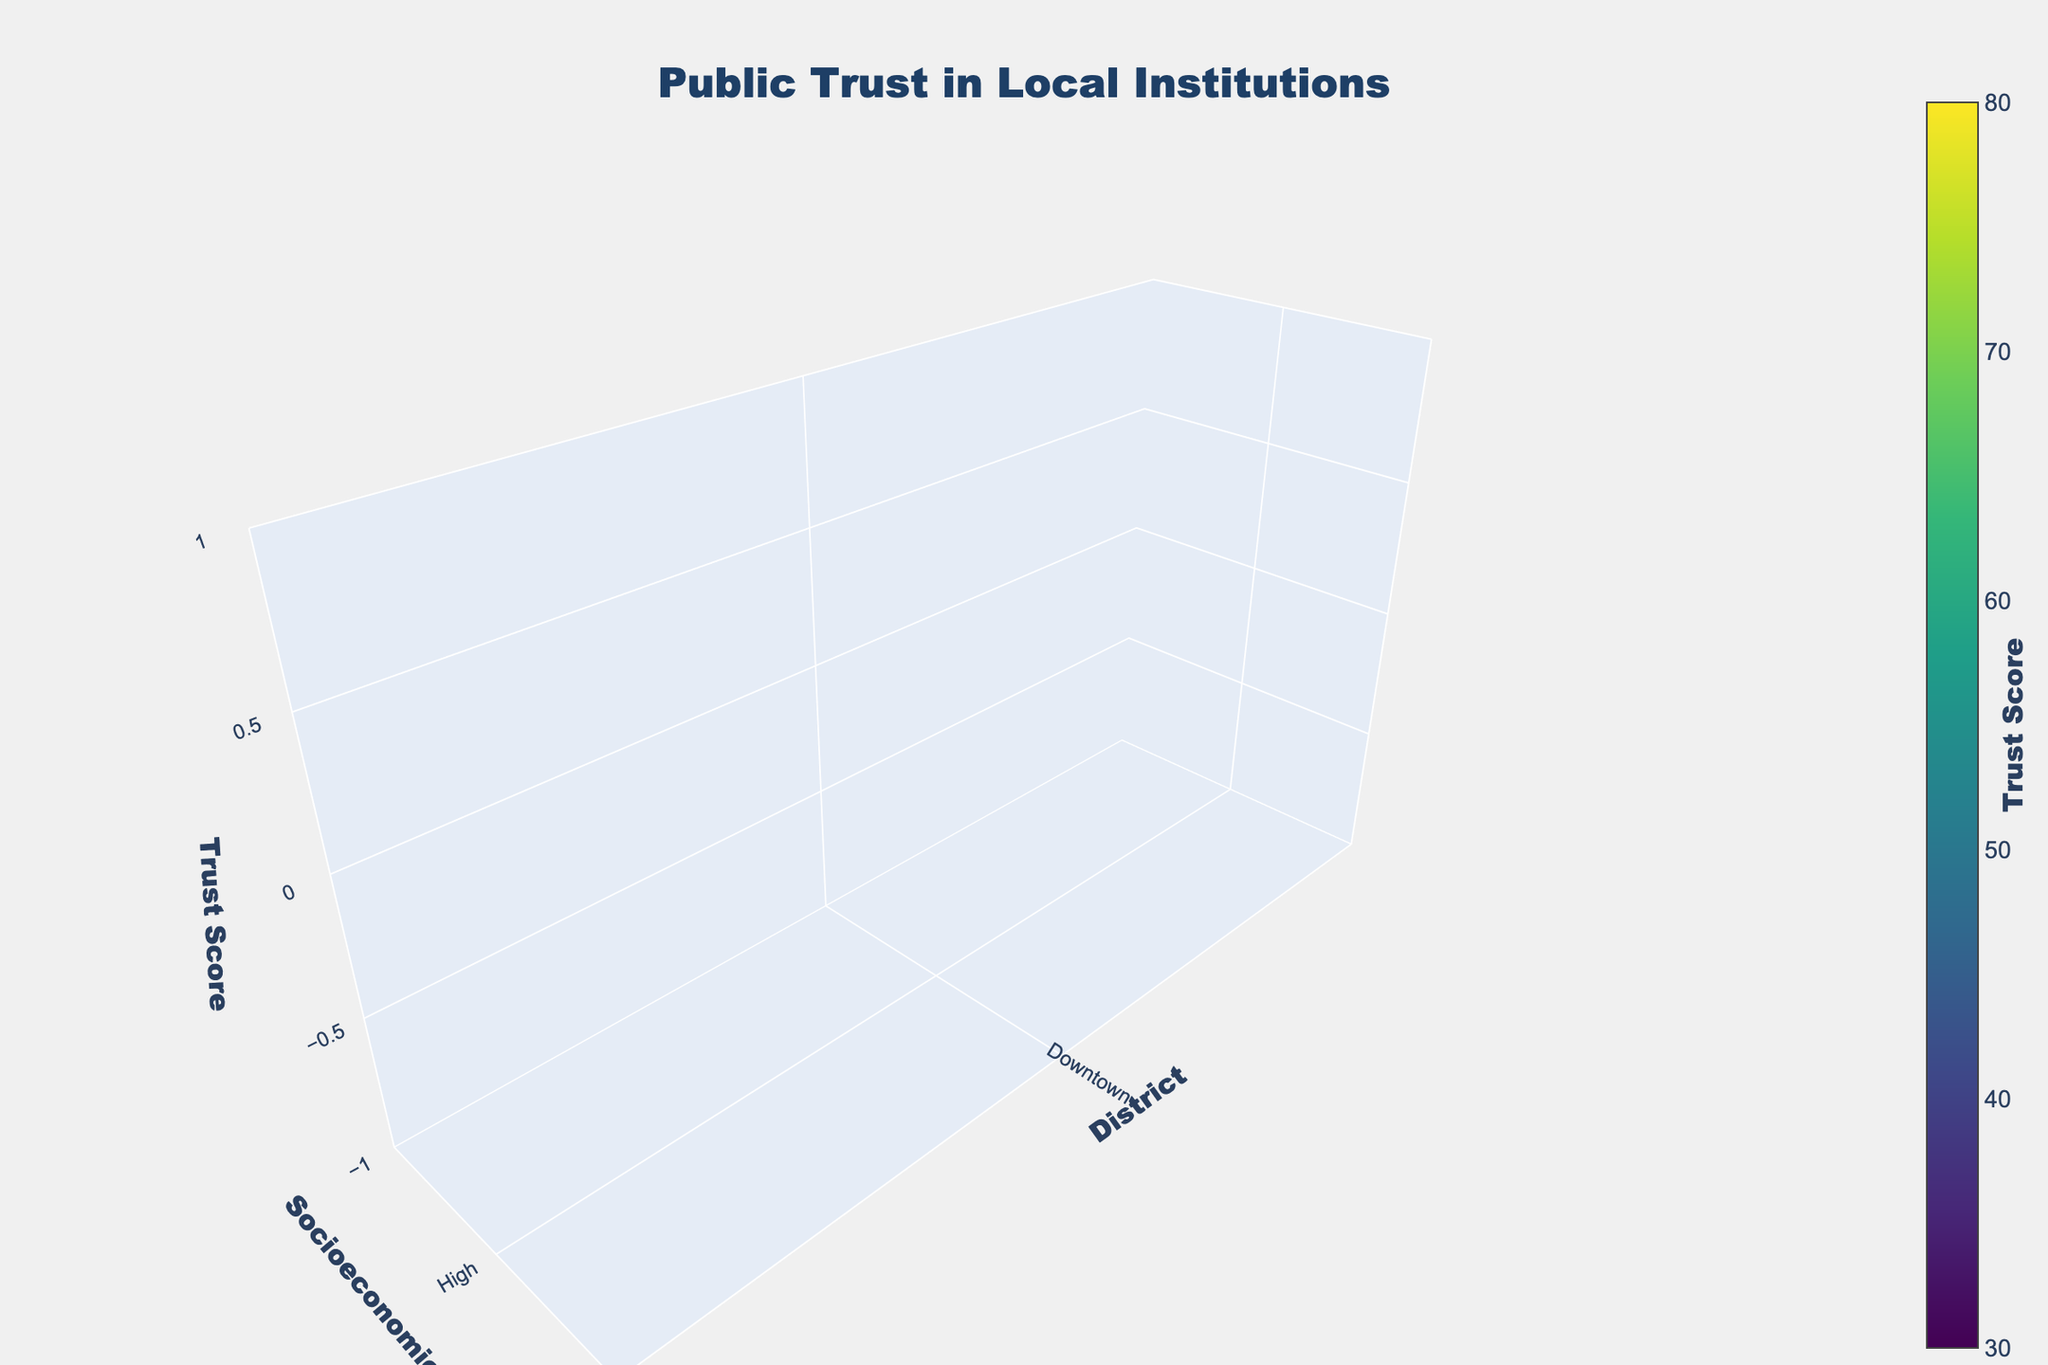What is the title of the figure? The title is located at the top of the plot. It reads 'Public Trust in Local Institutions'.
Answer: Public Trust in Local Institutions What are the labels on the axes? The axes labels are provided in the scene within the plot. The x-axis is labeled 'District', the y-axis is labeled 'Socioeconomic Level', and the z-axis is labeled 'Trust Score'.
Answer: District, Socioeconomic Level, Trust Score Which district has the highest trust score? Inspecting the z-axis values for each district, 'Suburbs' has the highest trust score with a value of 72 for the high socioeconomic level.
Answer: Suburbs How does the trust score vary across different socioeconomic levels in Downtown? By observing the plot, the trust scores in Downtown decrease from high to low socioeconomic levels: 65 for high, 58 for medium, and 42 for low.
Answer: 65, 58, 42 Compare the trust scores between University Area and Industrial for the high socioeconomic level. At the high socioeconomic level, University Area has a trust score of 71, while Industrial has a trust score of 59, which means University Area has a higher trust score.
Answer: University Area: 71, Industrial: 59 Which socioeconomic level exhibits the largest range of trust scores across all districts? To find the largest range, calculate the difference between the highest and lowest scores for each socioeconomic level. In this case, the high socioeconomic level has the largest range with values varying from 59 to 72.
Answer: High socioeconomic level What's the average trust score for the medium socioeconomic level across all districts? Add the trust scores for the medium level (58, 67, 51, 61, 63, 56, 64) and divide by the number of districts (7). Sum is 420, average is 420/7 = 60.
Answer: 60 Which district has the lowest trust score in any socioeconomic level, and what is the score? The lowest trust score observed by inspecting the lower bounds on the z-axis is in the Industrial district with a score of 38 for the low socioeconomic level.
Answer: Industrial, 38 Does the Business District have any socioeconomic level with a trust score greater than 60? By checking the trust scores in the Business District for all levels, the highest score is 63 for the high socioeconomic level, which is greater than 60.
Answer: Yes, 63 